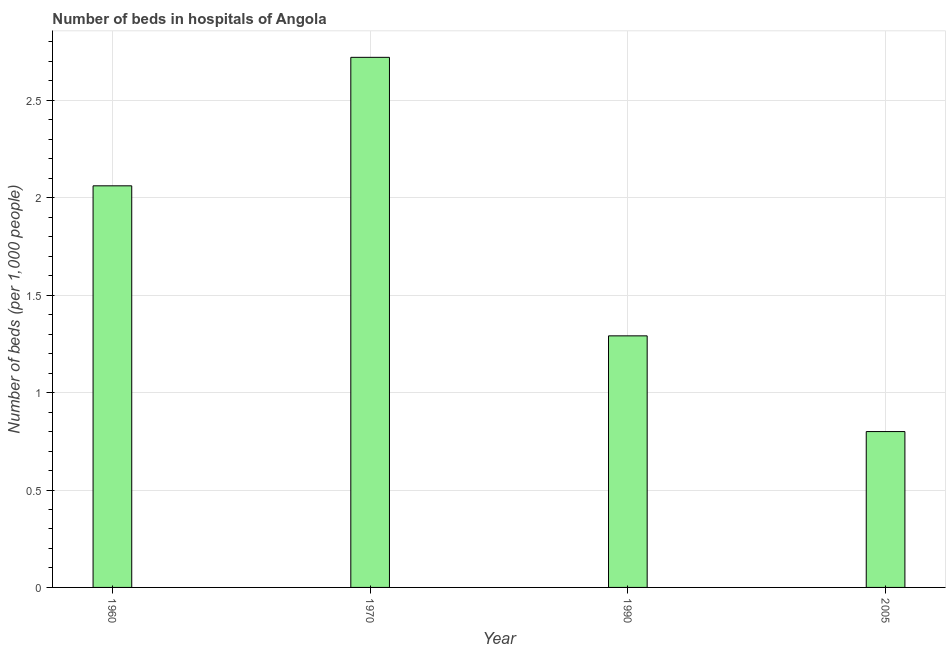Does the graph contain any zero values?
Your answer should be compact. No. Does the graph contain grids?
Offer a very short reply. Yes. What is the title of the graph?
Offer a very short reply. Number of beds in hospitals of Angola. What is the label or title of the Y-axis?
Your response must be concise. Number of beds (per 1,0 people). What is the number of hospital beds in 1990?
Your answer should be compact. 1.29. Across all years, what is the maximum number of hospital beds?
Give a very brief answer. 2.72. Across all years, what is the minimum number of hospital beds?
Make the answer very short. 0.8. What is the sum of the number of hospital beds?
Keep it short and to the point. 6.87. What is the difference between the number of hospital beds in 1960 and 2005?
Your answer should be very brief. 1.26. What is the average number of hospital beds per year?
Give a very brief answer. 1.72. What is the median number of hospital beds?
Provide a succinct answer. 1.68. Do a majority of the years between 1990 and 1960 (inclusive) have number of hospital beds greater than 0.7 %?
Offer a terse response. Yes. What is the ratio of the number of hospital beds in 1960 to that in 2005?
Ensure brevity in your answer.  2.58. Is the number of hospital beds in 1960 less than that in 2005?
Give a very brief answer. No. What is the difference between the highest and the second highest number of hospital beds?
Offer a terse response. 0.66. What is the difference between the highest and the lowest number of hospital beds?
Make the answer very short. 1.92. In how many years, is the number of hospital beds greater than the average number of hospital beds taken over all years?
Your answer should be compact. 2. How many years are there in the graph?
Keep it short and to the point. 4. Are the values on the major ticks of Y-axis written in scientific E-notation?
Ensure brevity in your answer.  No. What is the Number of beds (per 1,000 people) in 1960?
Keep it short and to the point. 2.06. What is the Number of beds (per 1,000 people) of 1970?
Your answer should be very brief. 2.72. What is the Number of beds (per 1,000 people) of 1990?
Ensure brevity in your answer.  1.29. What is the difference between the Number of beds (per 1,000 people) in 1960 and 1970?
Offer a terse response. -0.66. What is the difference between the Number of beds (per 1,000 people) in 1960 and 1990?
Offer a very short reply. 0.77. What is the difference between the Number of beds (per 1,000 people) in 1960 and 2005?
Your response must be concise. 1.26. What is the difference between the Number of beds (per 1,000 people) in 1970 and 1990?
Keep it short and to the point. 1.43. What is the difference between the Number of beds (per 1,000 people) in 1970 and 2005?
Give a very brief answer. 1.92. What is the difference between the Number of beds (per 1,000 people) in 1990 and 2005?
Offer a terse response. 0.49. What is the ratio of the Number of beds (per 1,000 people) in 1960 to that in 1970?
Your response must be concise. 0.76. What is the ratio of the Number of beds (per 1,000 people) in 1960 to that in 1990?
Keep it short and to the point. 1.6. What is the ratio of the Number of beds (per 1,000 people) in 1960 to that in 2005?
Keep it short and to the point. 2.58. What is the ratio of the Number of beds (per 1,000 people) in 1970 to that in 1990?
Make the answer very short. 2.11. What is the ratio of the Number of beds (per 1,000 people) in 1970 to that in 2005?
Your response must be concise. 3.4. What is the ratio of the Number of beds (per 1,000 people) in 1990 to that in 2005?
Provide a succinct answer. 1.61. 